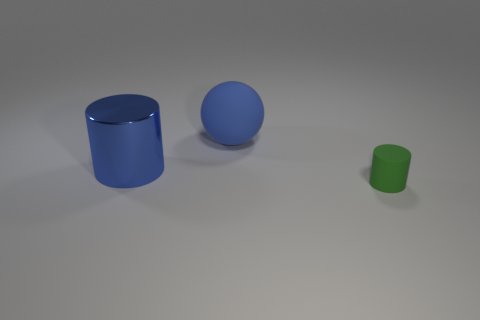What can you tell about the surface on which the objects are placed? The objects are placed on a matte, slightly reflective surface that creates subtle reflections right beneath them. The neutral gray color of the surface ensures that the attention remains on the objects themselves without any visual distractions. 